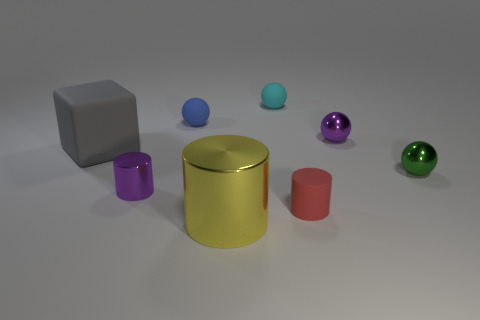There is a purple metal thing behind the tiny purple shiny thing left of the big metal cylinder; what is its shape?
Offer a very short reply. Sphere. How many blue matte spheres are the same size as the purple sphere?
Keep it short and to the point. 1. Is there a gray sphere?
Give a very brief answer. No. Is there anything else that is the same color as the tiny matte cylinder?
Your response must be concise. No. The red object that is made of the same material as the small blue ball is what shape?
Keep it short and to the point. Cylinder. What color is the small cylinder in front of the tiny purple object that is in front of the shiny ball that is in front of the big cube?
Give a very brief answer. Red. Are there an equal number of tiny cylinders in front of the green object and tiny green blocks?
Your answer should be compact. No. There is a large matte cube; is it the same color as the ball on the left side of the large metal cylinder?
Provide a short and direct response. No. There is a purple shiny thing on the right side of the metal object that is in front of the small red rubber cylinder; are there any tiny cyan objects behind it?
Keep it short and to the point. Yes. Are there fewer large yellow objects that are behind the yellow thing than small green cylinders?
Give a very brief answer. No. 